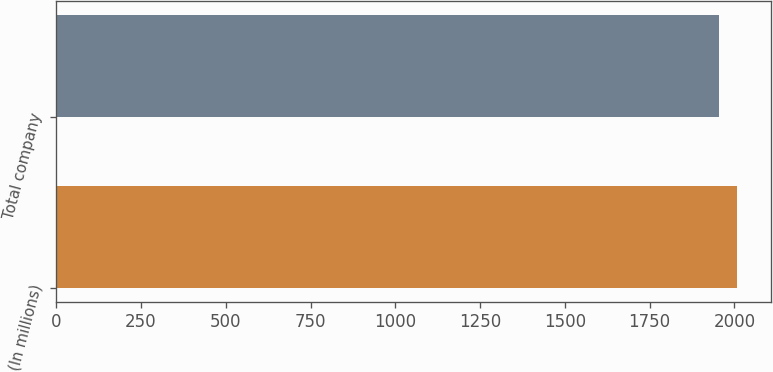<chart> <loc_0><loc_0><loc_500><loc_500><bar_chart><fcel>(In millions)<fcel>Total company<nl><fcel>2008<fcel>1954<nl></chart> 